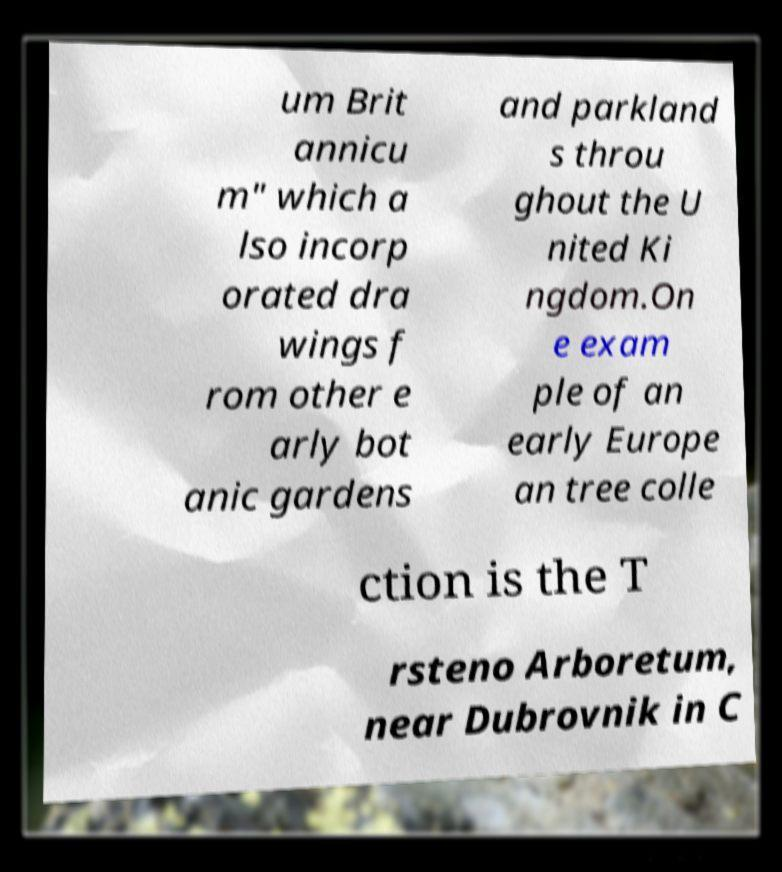I need the written content from this picture converted into text. Can you do that? um Brit annicu m" which a lso incorp orated dra wings f rom other e arly bot anic gardens and parkland s throu ghout the U nited Ki ngdom.On e exam ple of an early Europe an tree colle ction is the T rsteno Arboretum, near Dubrovnik in C 